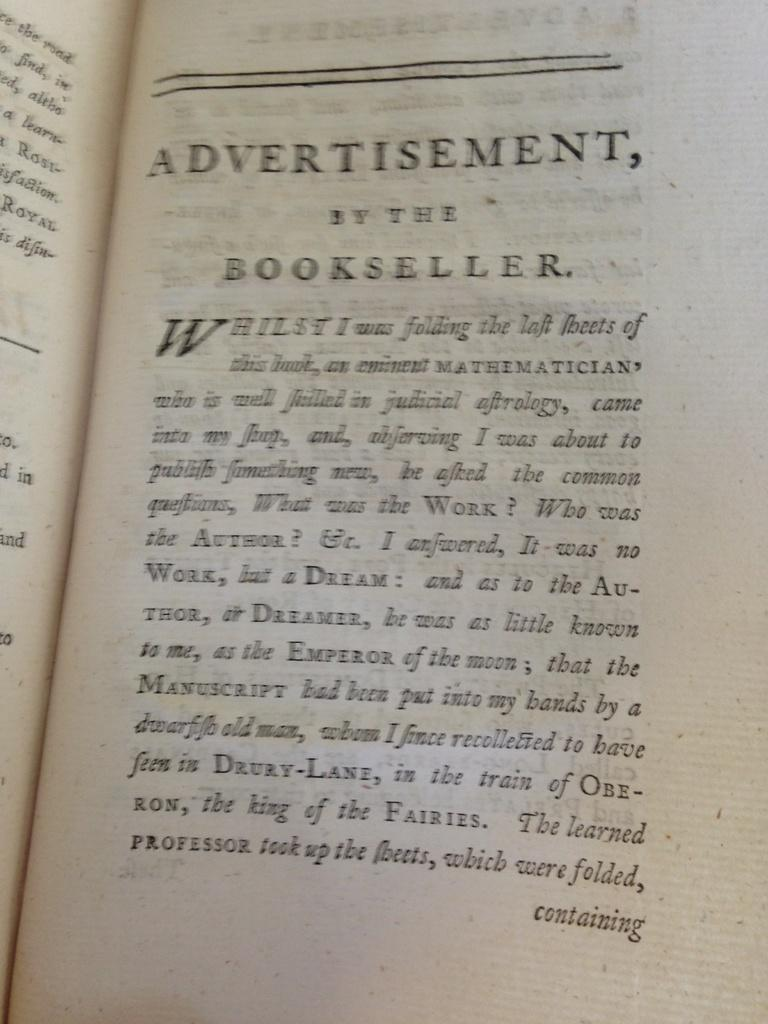<image>
Write a terse but informative summary of the picture. An open book called advertisement by the bookseller. 